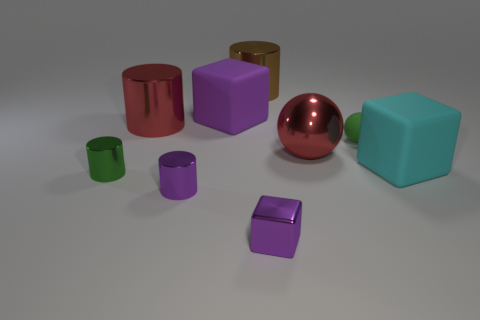What is the shape of the object that is the same color as the small matte sphere?
Keep it short and to the point. Cylinder. What shape is the purple metallic object that is on the right side of the small metallic cylinder that is in front of the small green thing in front of the matte ball?
Ensure brevity in your answer.  Cube. There is a small green rubber thing; does it have the same shape as the green object in front of the large cyan thing?
Make the answer very short. No. How many tiny things are either rubber blocks or purple metal blocks?
Provide a short and direct response. 1. Is there a rubber ball that has the same size as the brown cylinder?
Offer a very short reply. No. What is the color of the big rubber cube left of the big metal cylinder that is behind the purple block on the left side of the brown metal thing?
Make the answer very short. Purple. Does the small purple block have the same material as the large cylinder to the right of the red shiny cylinder?
Provide a short and direct response. Yes. The red thing that is the same shape as the brown thing is what size?
Offer a very short reply. Large. Are there an equal number of tiny green spheres that are to the right of the cyan rubber block and large purple rubber things that are behind the brown cylinder?
Ensure brevity in your answer.  Yes. What number of other objects are the same material as the green cylinder?
Your answer should be compact. 5. 